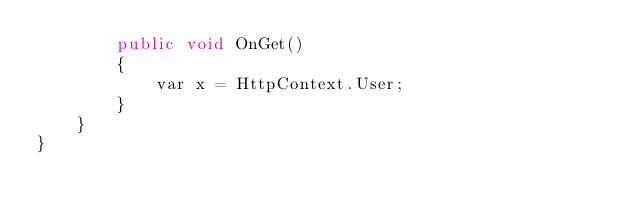<code> <loc_0><loc_0><loc_500><loc_500><_C#_>        public void OnGet()
        {
            var x = HttpContext.User;
        }
    }
}
</code> 